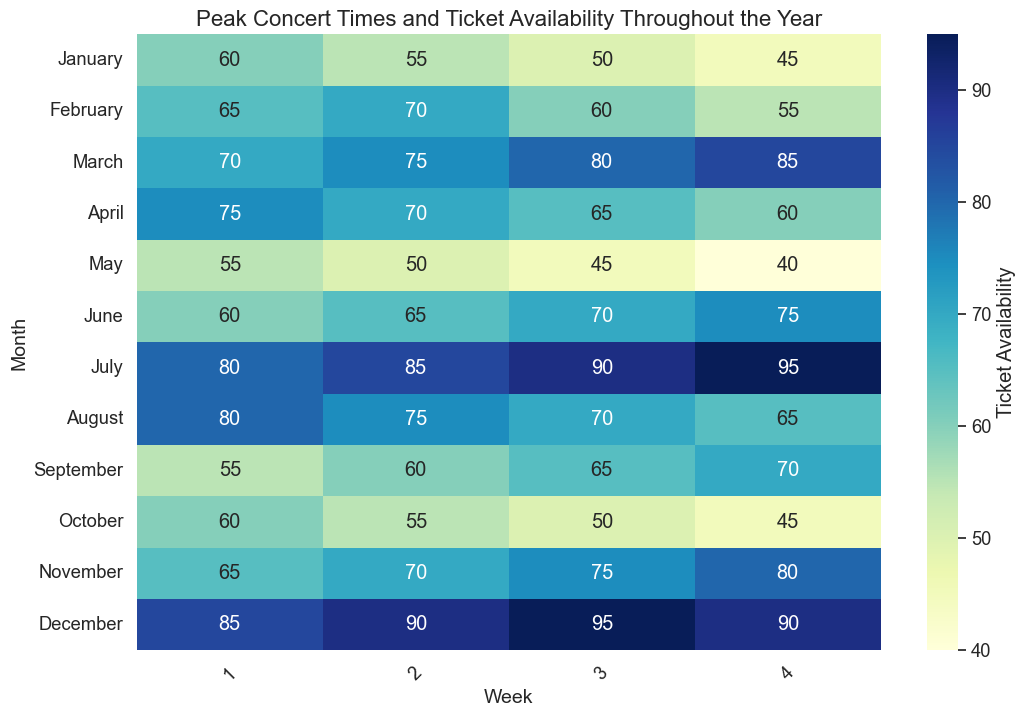What month has the most weeks with high ticket availability (80 or higher)? Check the heatmap to see which month has more weeks colored in dark blue, indicating higher availability. July and December have weeks with availability ≥ 80
Answer: July and December Which month has the lowest ticket availability overall? January has the lowest numbers (shades of lighter blue) across all weeks in its row compared to other months
Answer: January When is ticket availability highest during July? Observe the data within July and identify the week with the darkest blue. It's the 4th week with 95 tickets available
Answer: Week 4 How does ticket availability in April compare to October? Compare the heatmap colors and values in April and October. April has higher weekly values (all ≥ 60) than October (all ≤ 60)
Answer: April has higher availability What's the median ticket availability in May? May's weekly data are: 55, 50, 45, 40. Arrange them in order and find the middle value. For an even number of points: (45+50)/2 = 47.5
Answer: 47.5 Between March and November, which has a week with the highest ticket availability? March's peak is 85 and November's peak is 80. Compare the highest values within these months. March has a higher peak
Answer: March If I'm planning for September, which week would likely have the best ticket availability? In September, observe the color intensities and values. Week 4 shows the highest availability with 70
Answer: Week 4 What's the average ticket availability in January? Sum January’s weekly values: 60 + 55 + 50 + 45 = 210, then divide by the number of weeks: 210/4 = 52.5
Answer: 52.5 Do any months have a trend of decreasing ticket availability across its weeks? Look for months with a consistent decrease in values from Week 1 to Week 4. May shows this trend (55 to 40)
Answer: May What is the combined ticket availability for the third week of each month? Add up all values in the third week column: 50+60+80+65+45+70+90+70+65+50+75+95 = 815
Answer: 815 